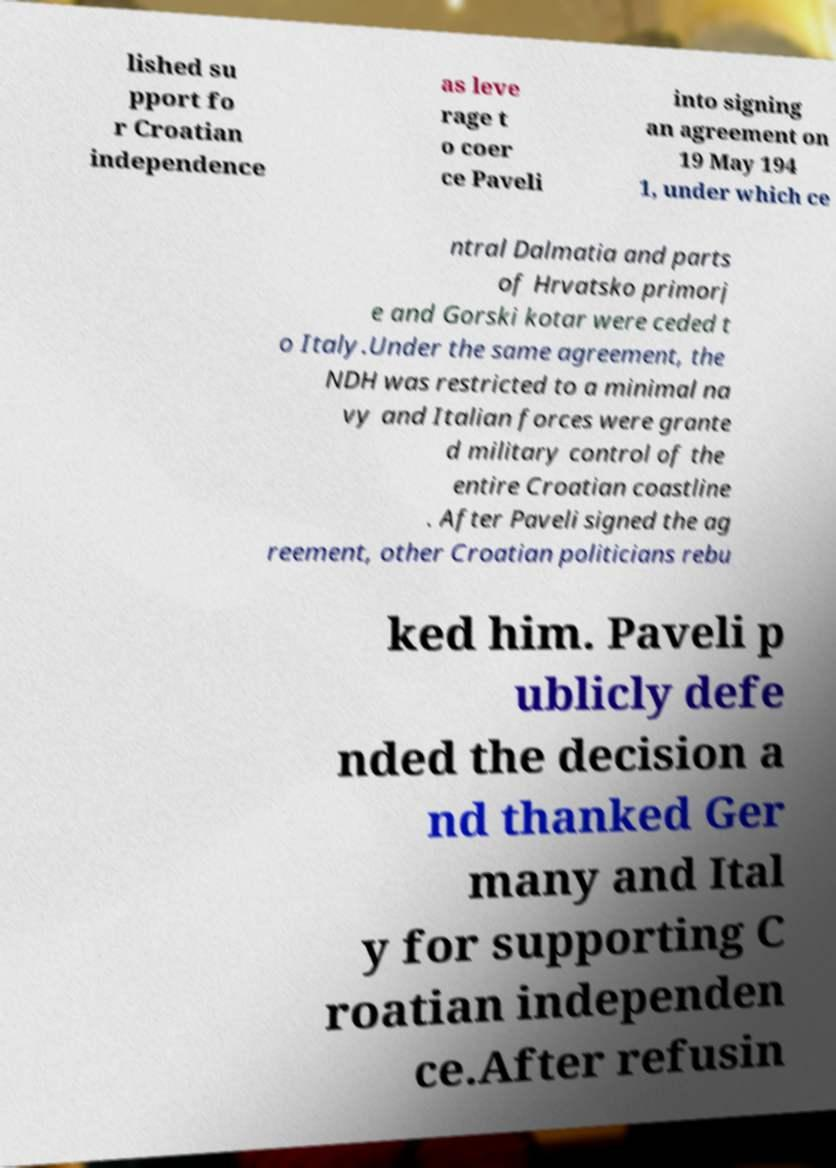There's text embedded in this image that I need extracted. Can you transcribe it verbatim? lished su pport fo r Croatian independence as leve rage t o coer ce Paveli into signing an agreement on 19 May 194 1, under which ce ntral Dalmatia and parts of Hrvatsko primorj e and Gorski kotar were ceded t o Italy.Under the same agreement, the NDH was restricted to a minimal na vy and Italian forces were grante d military control of the entire Croatian coastline . After Paveli signed the ag reement, other Croatian politicians rebu ked him. Paveli p ublicly defe nded the decision a nd thanked Ger many and Ital y for supporting C roatian independen ce.After refusin 